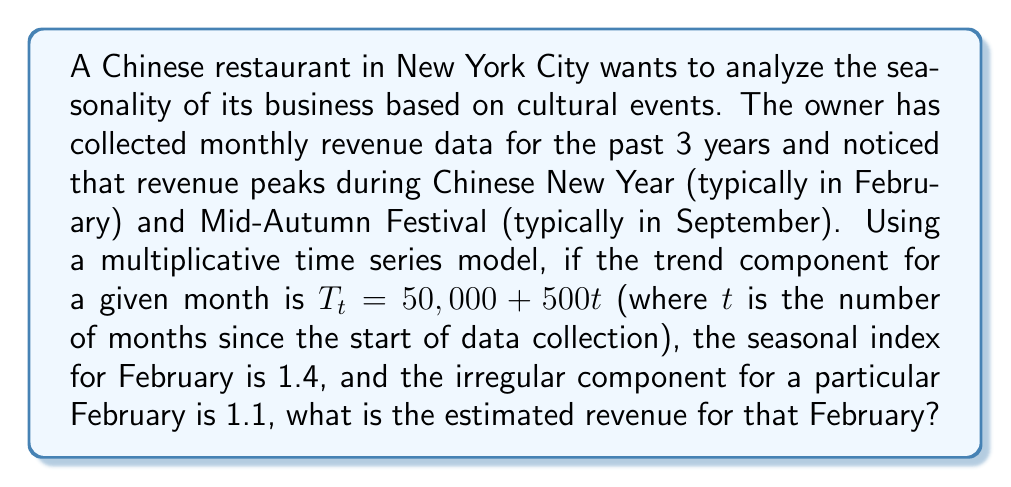What is the answer to this math problem? To solve this problem, we'll use the multiplicative time series model:

$$Y_t = T_t \times S_t \times I_t$$

Where:
$Y_t$ is the observed value (revenue in this case)
$T_t$ is the trend component
$S_t$ is the seasonal component
$I_t$ is the irregular component

We are given:
1. Trend component: $T_t = 50,000 + 500t$
2. Seasonal index for February: $S_t = 1.4$
3. Irregular component for this particular February: $I_t = 1.1$

To find the revenue, we need to:
1. Determine the value of $t$ for February in question (assuming it's the most recent February in the 3-year data)
2. Calculate the trend component $T_t$
3. Multiply all components together

Step 1: Determining $t$
If we have 3 years of data, the most recent February would be in the 26th month (2 years and 2 months). So, $t = 26$.

Step 2: Calculating $T_t$
$$T_t = 50,000 + 500(26) = 50,000 + 13,000 = 63,000$$

Step 3: Multiplying all components
$$Y_t = T_t \times S_t \times I_t = 63,000 \times 1.4 \times 1.1$$
Answer: $$Y_t = 63,000 \times 1.4 \times 1.1 = 96,810$$

The estimated revenue for that February is $96,810. 